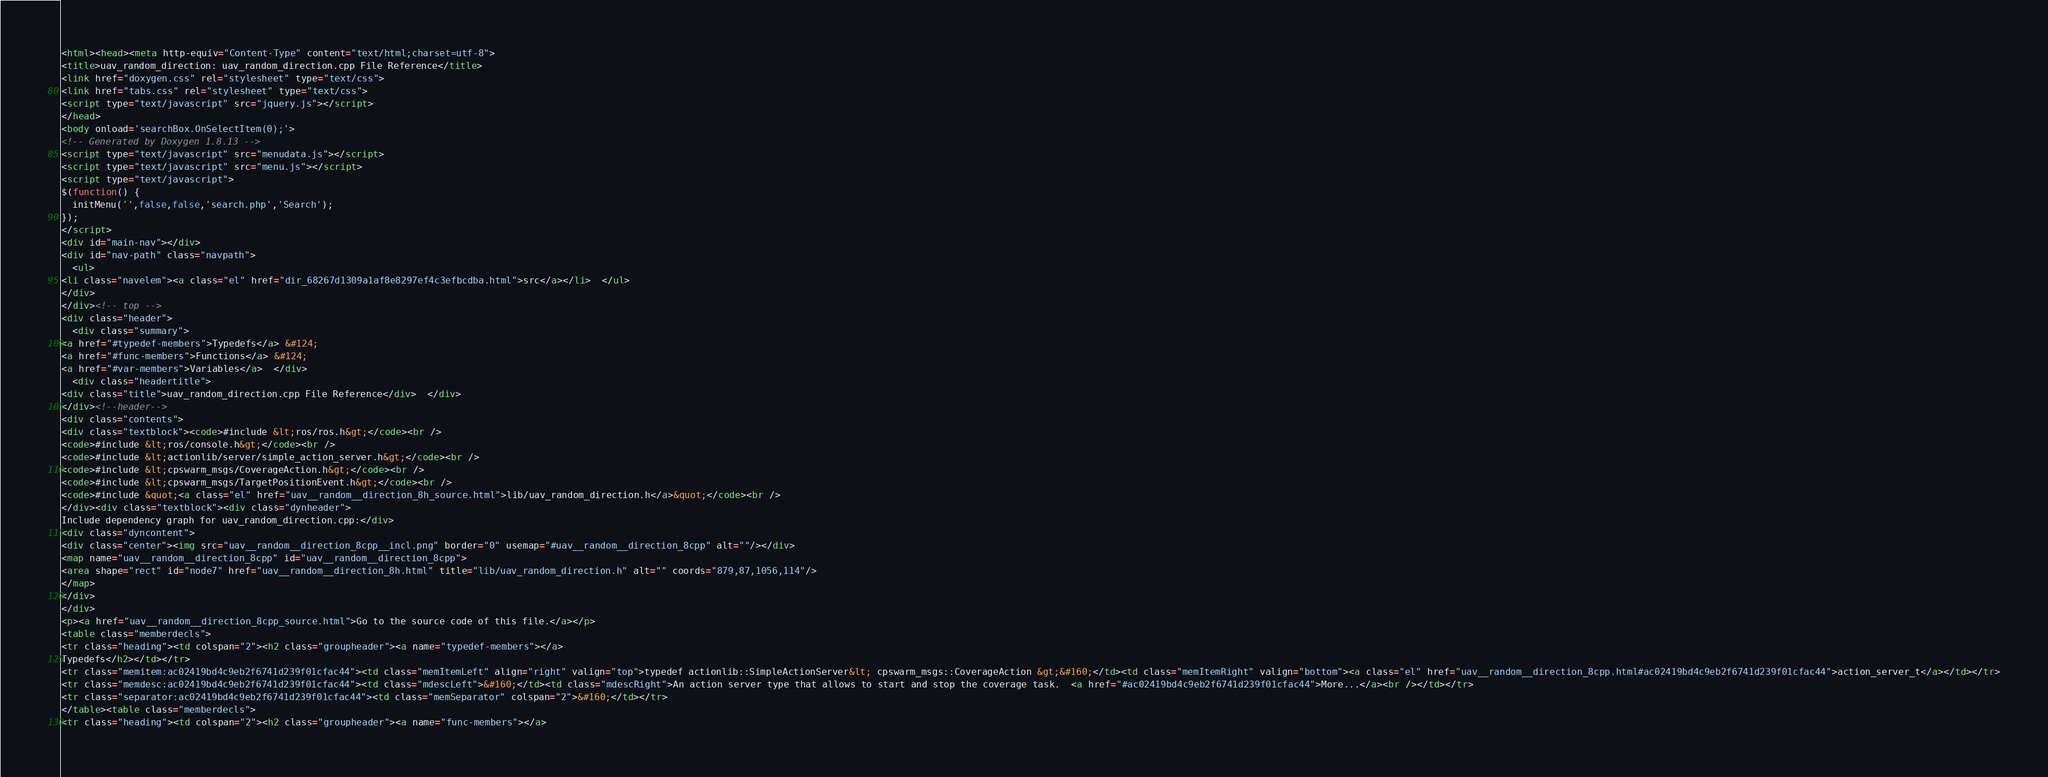Convert code to text. <code><loc_0><loc_0><loc_500><loc_500><_HTML_><html><head><meta http-equiv="Content-Type" content="text/html;charset=utf-8">
<title>uav_random_direction: uav_random_direction.cpp File Reference</title>
<link href="doxygen.css" rel="stylesheet" type="text/css">
<link href="tabs.css" rel="stylesheet" type="text/css">
<script type="text/javascript" src="jquery.js"></script>
</head>
<body onload='searchBox.OnSelectItem(0);'>
<!-- Generated by Doxygen 1.8.13 -->
<script type="text/javascript" src="menudata.js"></script>
<script type="text/javascript" src="menu.js"></script>
<script type="text/javascript">
$(function() {
  initMenu('',false,false,'search.php','Search');
});
</script>
<div id="main-nav"></div>
<div id="nav-path" class="navpath">
  <ul>
<li class="navelem"><a class="el" href="dir_68267d1309a1af8e8297ef4c3efbcdba.html">src</a></li>  </ul>
</div>
</div><!-- top -->
<div class="header">
  <div class="summary">
<a href="#typedef-members">Typedefs</a> &#124;
<a href="#func-members">Functions</a> &#124;
<a href="#var-members">Variables</a>  </div>
  <div class="headertitle">
<div class="title">uav_random_direction.cpp File Reference</div>  </div>
</div><!--header-->
<div class="contents">
<div class="textblock"><code>#include &lt;ros/ros.h&gt;</code><br />
<code>#include &lt;ros/console.h&gt;</code><br />
<code>#include &lt;actionlib/server/simple_action_server.h&gt;</code><br />
<code>#include &lt;cpswarm_msgs/CoverageAction.h&gt;</code><br />
<code>#include &lt;cpswarm_msgs/TargetPositionEvent.h&gt;</code><br />
<code>#include &quot;<a class="el" href="uav__random__direction_8h_source.html">lib/uav_random_direction.h</a>&quot;</code><br />
</div><div class="textblock"><div class="dynheader">
Include dependency graph for uav_random_direction.cpp:</div>
<div class="dyncontent">
<div class="center"><img src="uav__random__direction_8cpp__incl.png" border="0" usemap="#uav__random__direction_8cpp" alt=""/></div>
<map name="uav__random__direction_8cpp" id="uav__random__direction_8cpp">
<area shape="rect" id="node7" href="uav__random__direction_8h.html" title="lib/uav_random_direction.h" alt="" coords="879,87,1056,114"/>
</map>
</div>
</div>
<p><a href="uav__random__direction_8cpp_source.html">Go to the source code of this file.</a></p>
<table class="memberdecls">
<tr class="heading"><td colspan="2"><h2 class="groupheader"><a name="typedef-members"></a>
Typedefs</h2></td></tr>
<tr class="memitem:ac02419bd4c9eb2f6741d239f01cfac44"><td class="memItemLeft" align="right" valign="top">typedef actionlib::SimpleActionServer&lt; cpswarm_msgs::CoverageAction &gt;&#160;</td><td class="memItemRight" valign="bottom"><a class="el" href="uav__random__direction_8cpp.html#ac02419bd4c9eb2f6741d239f01cfac44">action_server_t</a></td></tr>
<tr class="memdesc:ac02419bd4c9eb2f6741d239f01cfac44"><td class="mdescLeft">&#160;</td><td class="mdescRight">An action server type that allows to start and stop the coverage task.  <a href="#ac02419bd4c9eb2f6741d239f01cfac44">More...</a><br /></td></tr>
<tr class="separator:ac02419bd4c9eb2f6741d239f01cfac44"><td class="memSeparator" colspan="2">&#160;</td></tr>
</table><table class="memberdecls">
<tr class="heading"><td colspan="2"><h2 class="groupheader"><a name="func-members"></a></code> 